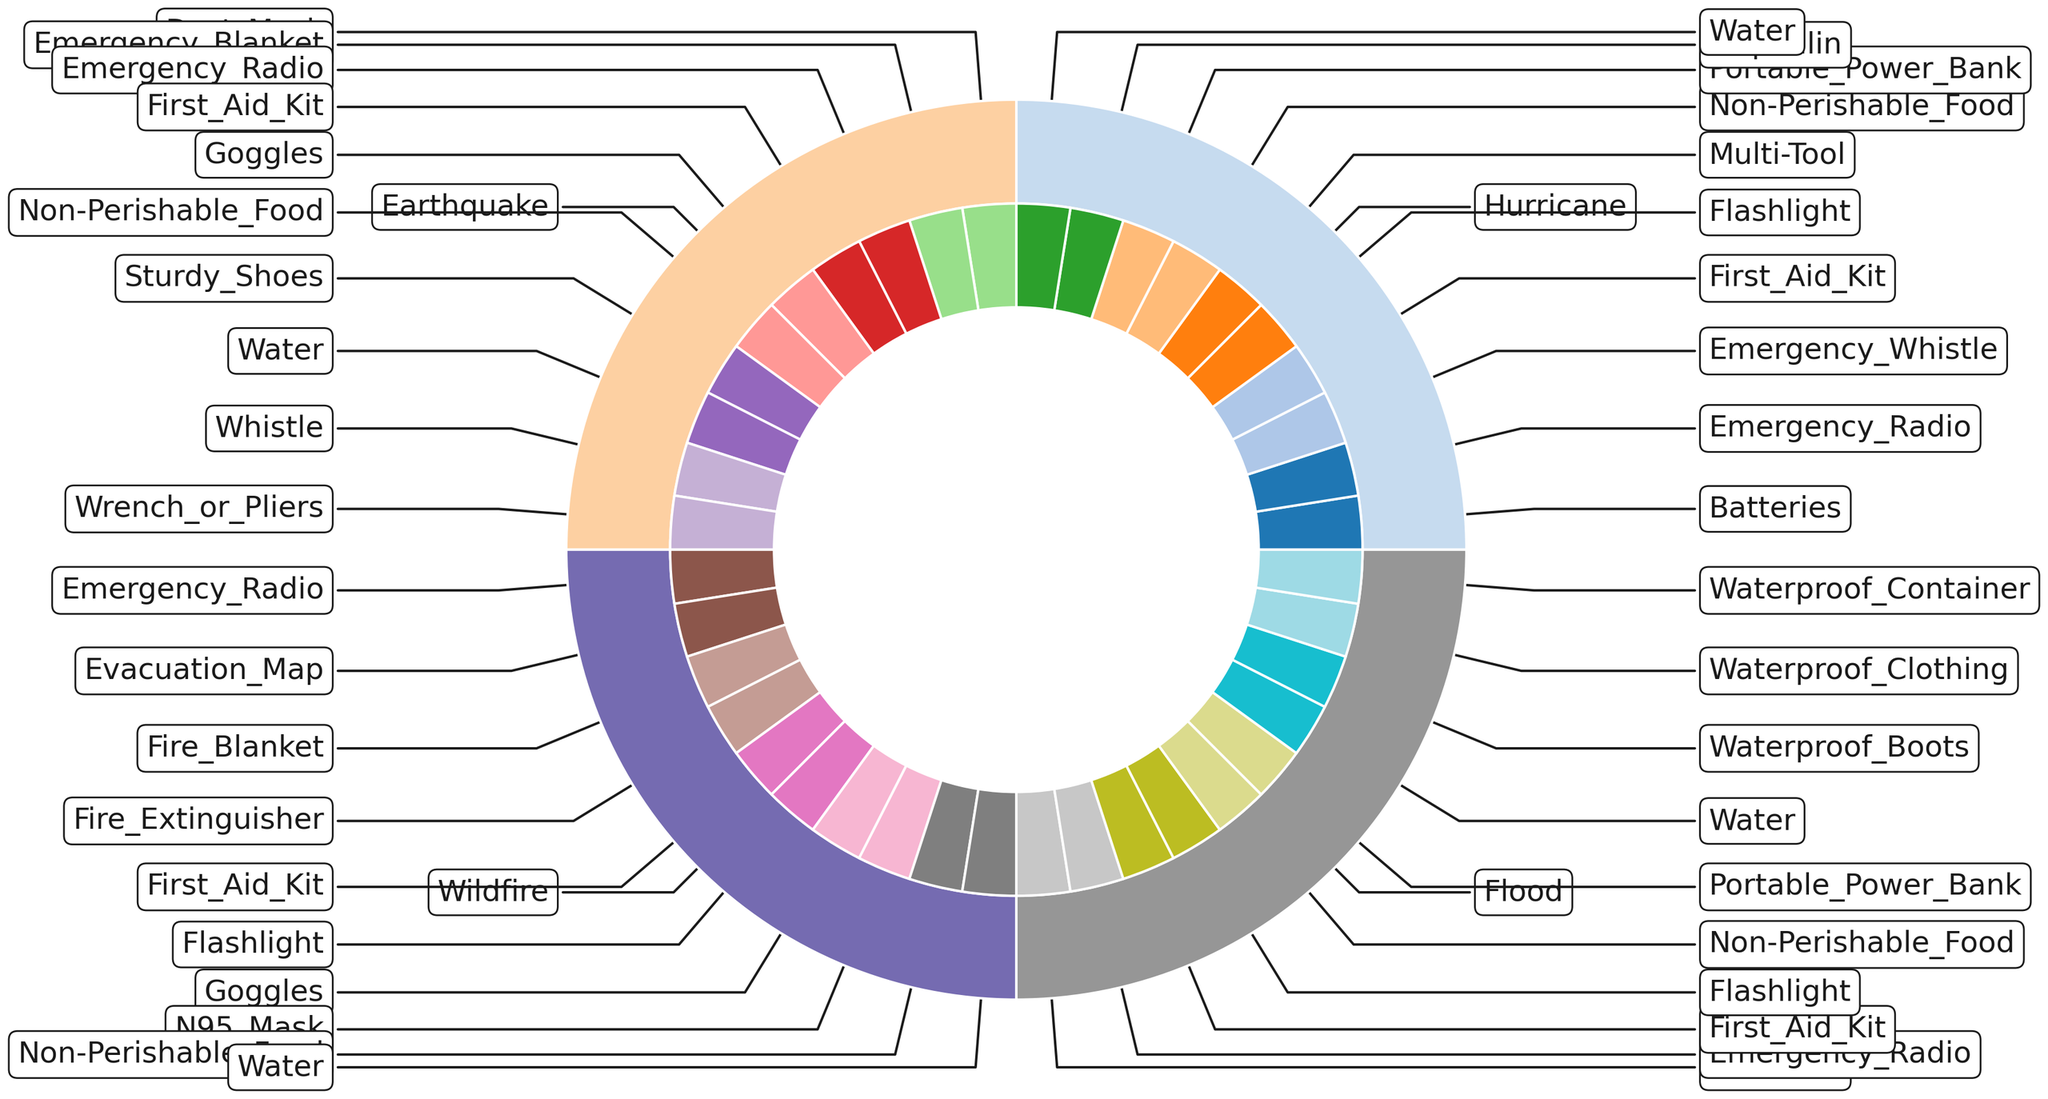What is the most common essential equipment for hurricanes? By observing the chart, identify the segment in the "Hurricane" section with the largest portion. This segment corresponds to the essential equipment with the highest count for hurricanes.
Answer: First_Aid_Kit Compare the number of essential equipment items for wildfires and floods. Which has more unique items listed? Count the segments within the "Wildfire" and "Flood" sections. The number of segments represents the unique items listed for each.
Answer: Wildfire How many essential equipment items are shared across all natural disasters? Identify and count the segments that appear within each section (e.g., "First_Aid_Kit" and "Emergency_Radio").
Answer: 2 What proportion of all items for earthquakes are dedicated to safety? First, count the segments in the "Earthquake" section. Then, identify and count safety-related items (e.g., "Dust_Mask," "Goggles"). Divide the number of safety items by the total number of items for earthquakes.
Answer: 5 out of 10 Which section (natural disaster) features the least number of items? Determine which outer segment is the smallest by visual inspection, indicating the disaster with the fewest essential items listed.
Answer: Flood What is the ratio of “First_Aid_Kit” occurrences between wildfires and hurricanes? Count the segments labeled "First_Aid_Kit" in both "Wildfire" and "Hurricane" sections. Then divide the count for wildfires by the count for hurricanes.
Answer: 1:1 If you combine the counts of emergency radios for all disasters, what is the total? Add the segments labeled "Emergency_Radio" within each disaster section ("Hurricane," "Earthquake," "Wildfire," and "Flood").
Answer: 4 What is the most unique essential equipment for floods when compared to other natural disasters? Identify the segment in the "Flood" section that does not appear in the other disaster categories.
Answer: Waterproof_Container 